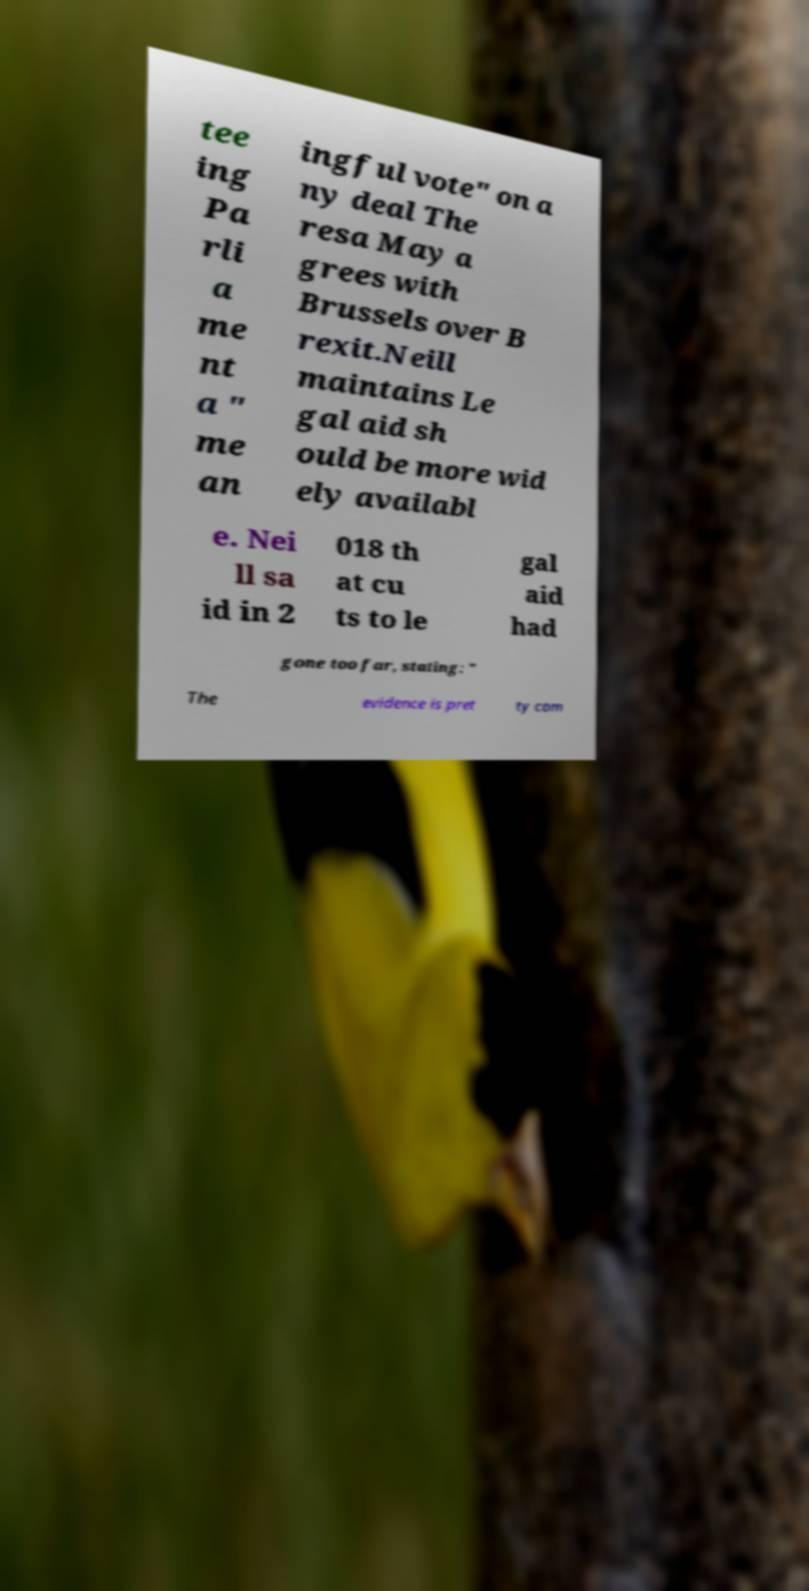For documentation purposes, I need the text within this image transcribed. Could you provide that? tee ing Pa rli a me nt a " me an ingful vote" on a ny deal The resa May a grees with Brussels over B rexit.Neill maintains Le gal aid sh ould be more wid ely availabl e. Nei ll sa id in 2 018 th at cu ts to le gal aid had gone too far, stating: " The evidence is pret ty com 